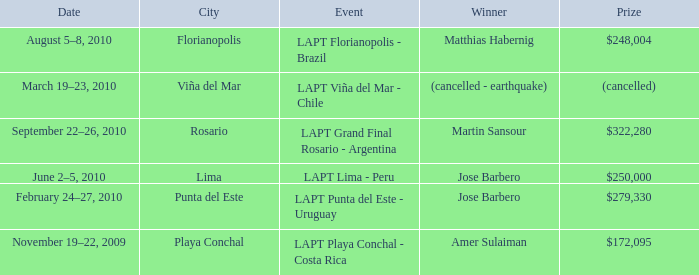What is the date amer sulaiman won? November 19–22, 2009. 